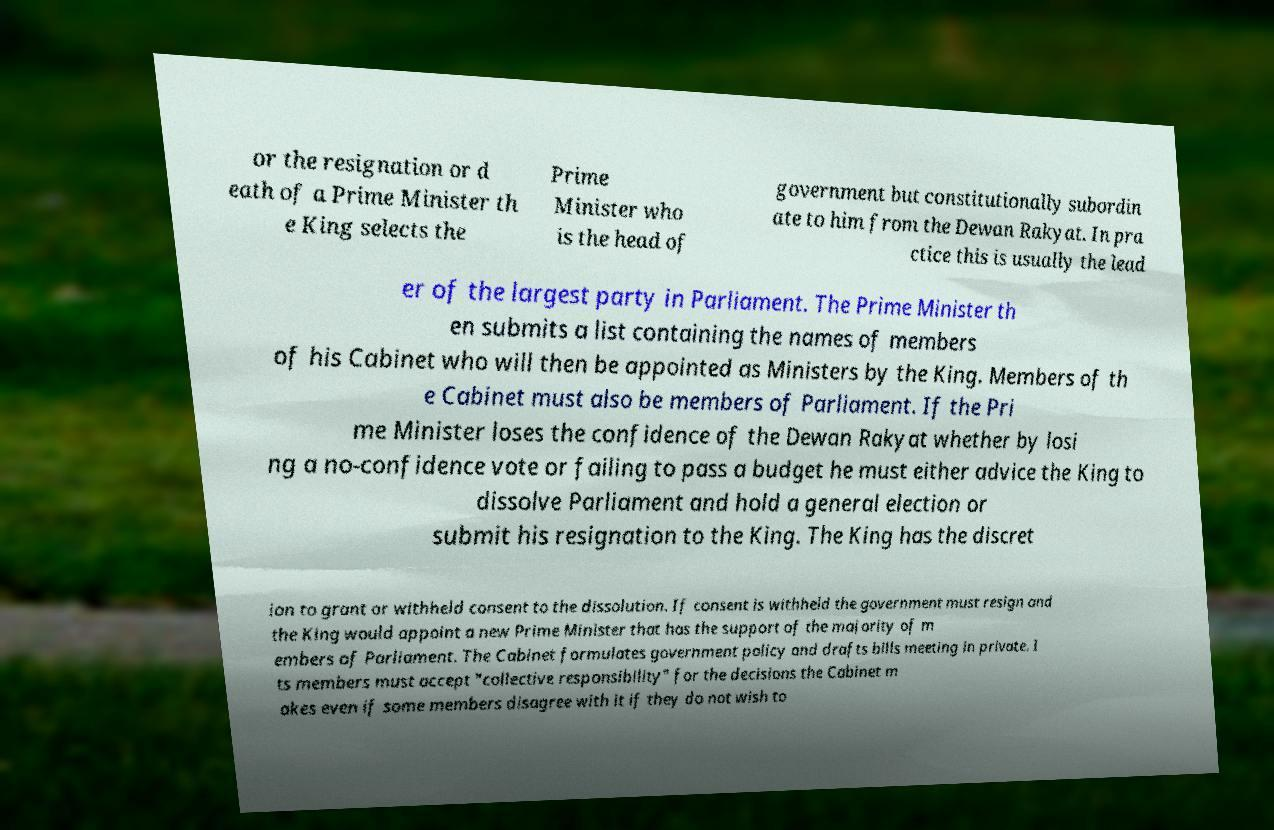There's text embedded in this image that I need extracted. Can you transcribe it verbatim? or the resignation or d eath of a Prime Minister th e King selects the Prime Minister who is the head of government but constitutionally subordin ate to him from the Dewan Rakyat. In pra ctice this is usually the lead er of the largest party in Parliament. The Prime Minister th en submits a list containing the names of members of his Cabinet who will then be appointed as Ministers by the King. Members of th e Cabinet must also be members of Parliament. If the Pri me Minister loses the confidence of the Dewan Rakyat whether by losi ng a no-confidence vote or failing to pass a budget he must either advice the King to dissolve Parliament and hold a general election or submit his resignation to the King. The King has the discret ion to grant or withheld consent to the dissolution. If consent is withheld the government must resign and the King would appoint a new Prime Minister that has the support of the majority of m embers of Parliament. The Cabinet formulates government policy and drafts bills meeting in private. I ts members must accept "collective responsibility" for the decisions the Cabinet m akes even if some members disagree with it if they do not wish to 